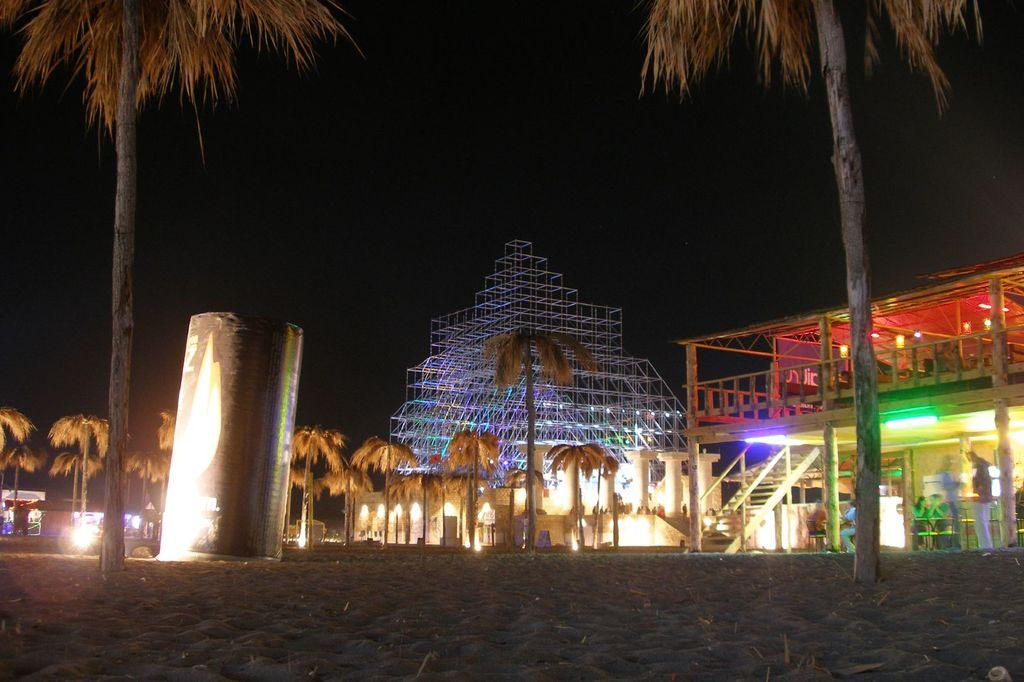What is the main feature of the image? There are many trees in the image. Can you describe any other objects or structures in the image? There is an object in the image, and there is a shed to the right of the image. What is the shed made of? The shed is made up of metal rods. Are there any visible light sources in the image? Yes, there are lights visible in the image. What is the color of the background in the image? The background of the image is black. What type of mass is being offered in the image? There is no indication of a mass or any religious ceremony in the image. The image primarily features trees, an object, a shed, and lights. 